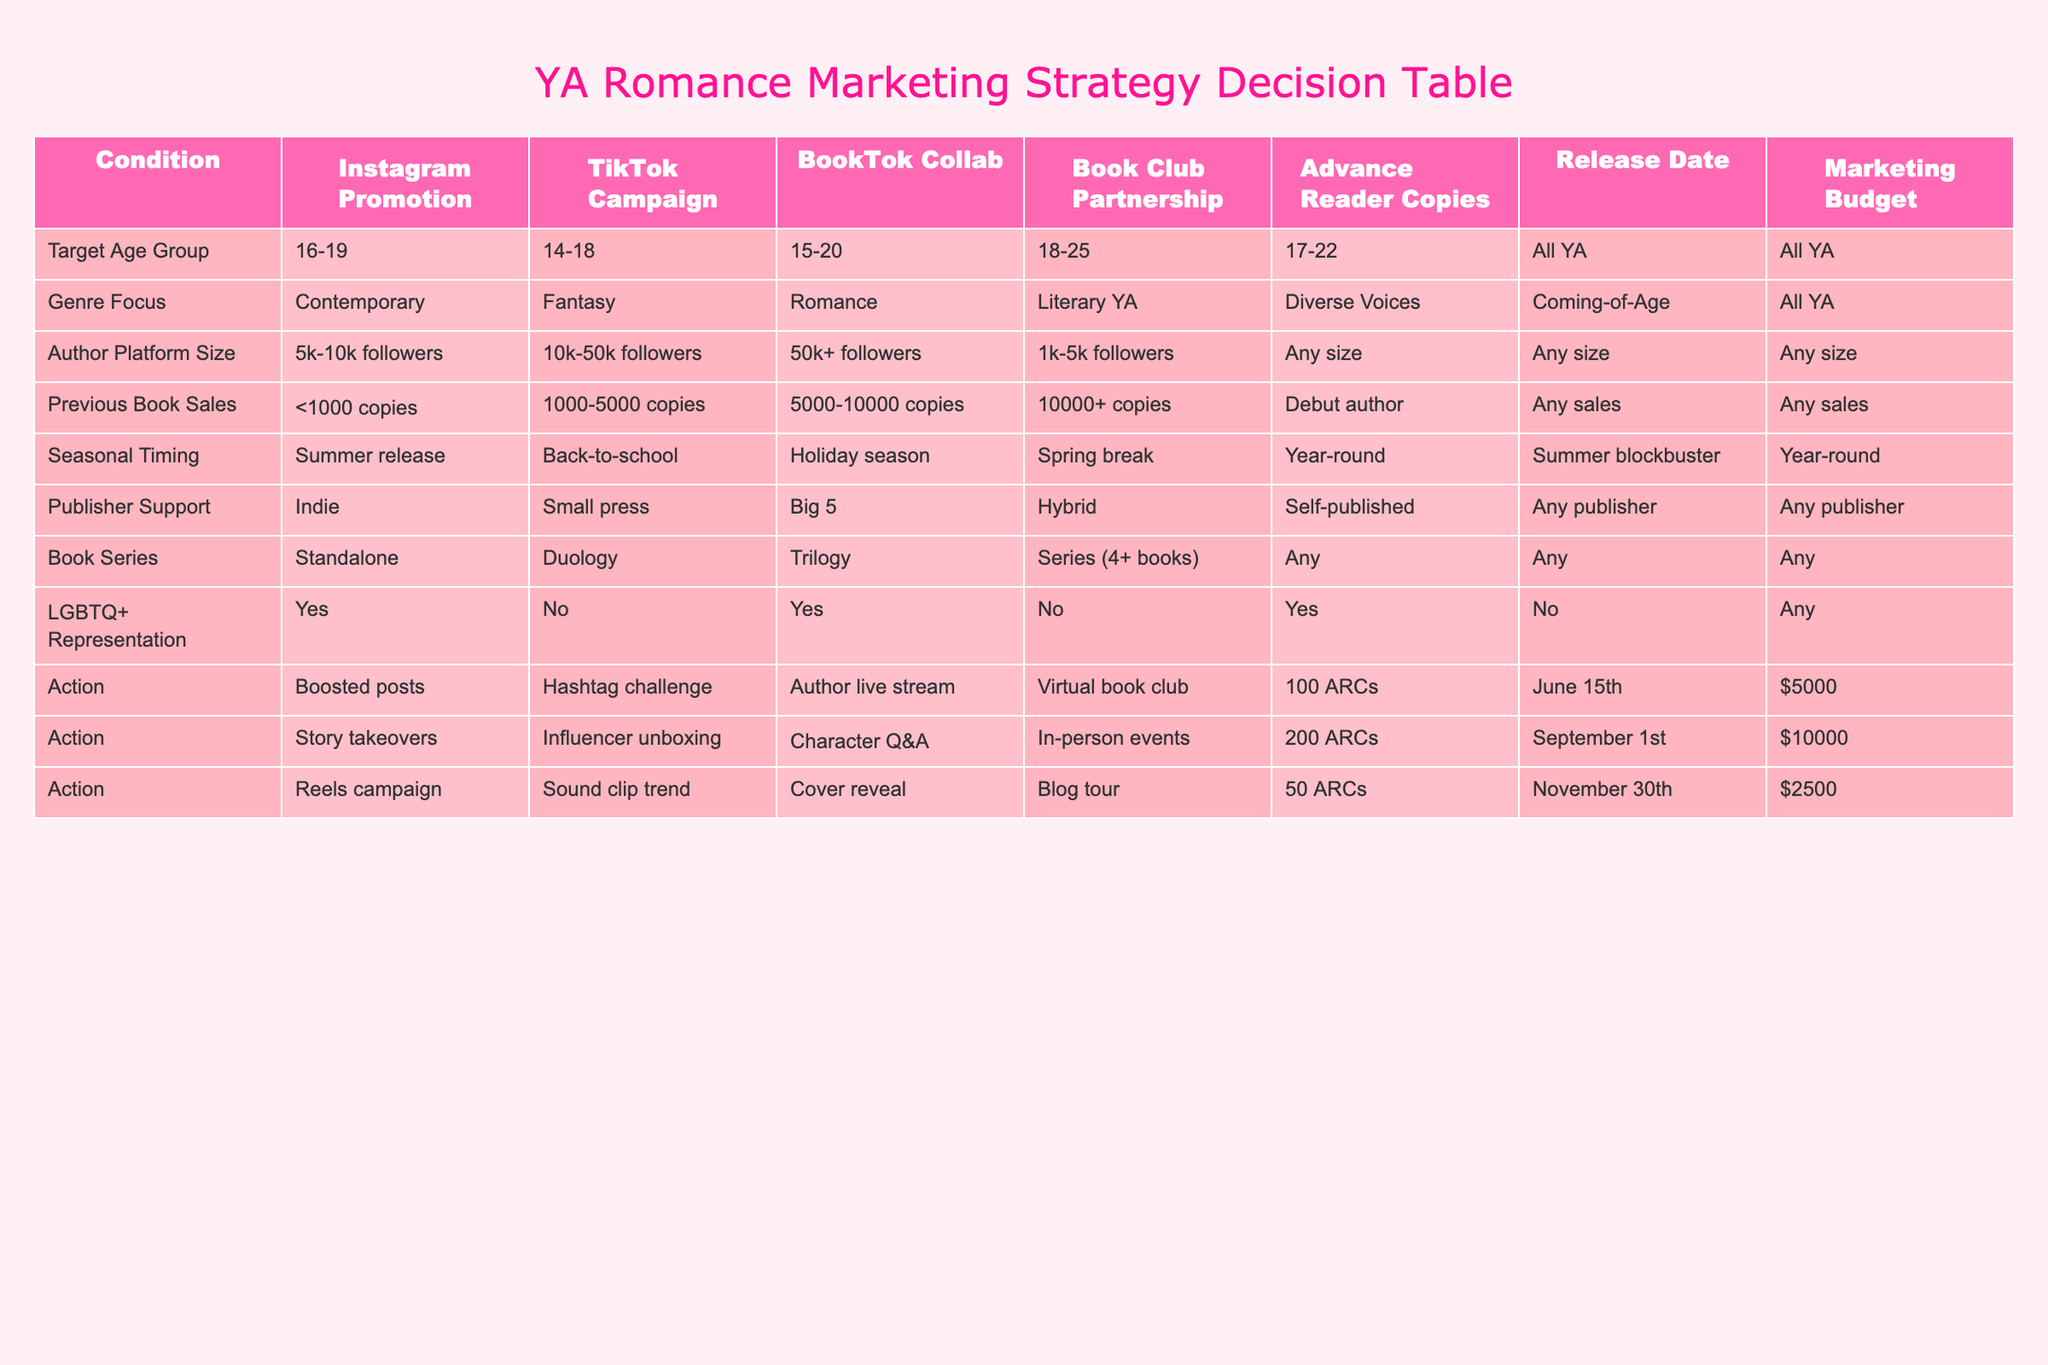What is the target age group for the TikTok Campaign? The TikTok Campaign targets the age group of 14-18, which is specified in the "Target Age Group" column of the table for that action.
Answer: 14-18 Which action corresponds to a September 1st release date? The action that corresponds to a September 1st release date is the "Story takeovers" action, as noted in the "Release Date" column for that row.
Answer: Story takeovers For the Book Club Partnership, what is the LGBTQ+ representation status? The Book Club Partnership has a status of "No" for LGBTQ+ representation, as indicated in the column corresponding to that action.
Answer: No How many ARCs are allocated for the "Virtual book club" action? The "Virtual book club" action allocates 100 Advance Reader Copies (ARCs), which can be found in the "Advance Reader Copies" column for that action in the table.
Answer: 100 What is the total marketing budget for the three actions listed? To find the total marketing budget, add the budgets for all three actions: $5000 (Boosted posts) + $10000 (Story takeovers) + $2500 (Reels campaign) = $17500.
Answer: $17500 Is it true that a Trilogy can be supported by a TikTok Campaign? Yes, it is true because the table indicates that a Trilogy falls under the "Any" category, which means it can be supported by any marketing action including the TikTok Campaign.
Answer: Yes Which action has the highest author platform size requirement? The "BookTok Collab" requires an author platform size of 50k+ followers, which is the highest requirement compared to other actions listed in the table.
Answer: 50k+ followers What is the average number of ARCs provided across all actions? The number of ARCs provided are 100, 200, and 50 for the three actions. The average is (100 + 200 + 50) / 3 = 116.67, which can be rounded to 117.
Answer: 117 Does the "Sound clip trend" require a specific genre focus? No, the "Sound clip trend" does not require a specific genre focus as it is categorized under "Any size" in terms of genre, indicating flexibility.
Answer: No 